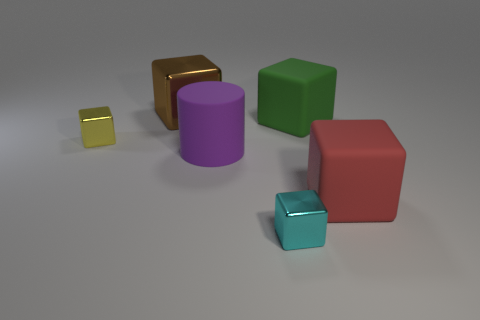How many things are either small yellow metal things or large blue shiny cylinders? In the image, there is one small yellow cube that appears to be metallic, and there are no large blue shiny cylinders present. Therefore, the total count of items meeting either criterion is just one. 